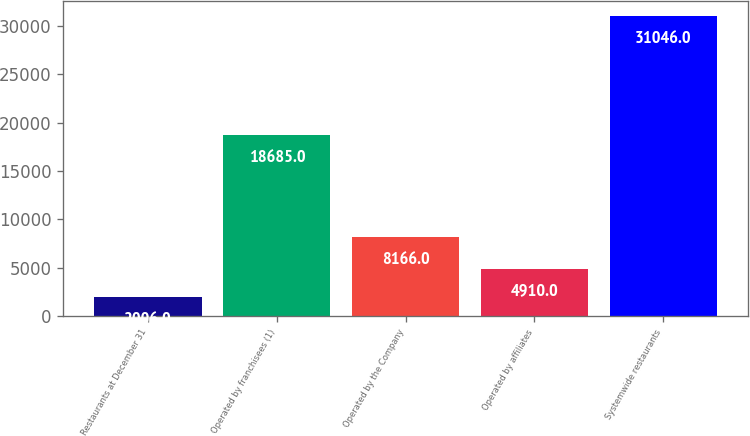Convert chart. <chart><loc_0><loc_0><loc_500><loc_500><bar_chart><fcel>Restaurants at December 31<fcel>Operated by franchisees (1)<fcel>Operated by the Company<fcel>Operated by affiliates<fcel>Systemwide restaurants<nl><fcel>2006<fcel>18685<fcel>8166<fcel>4910<fcel>31046<nl></chart> 